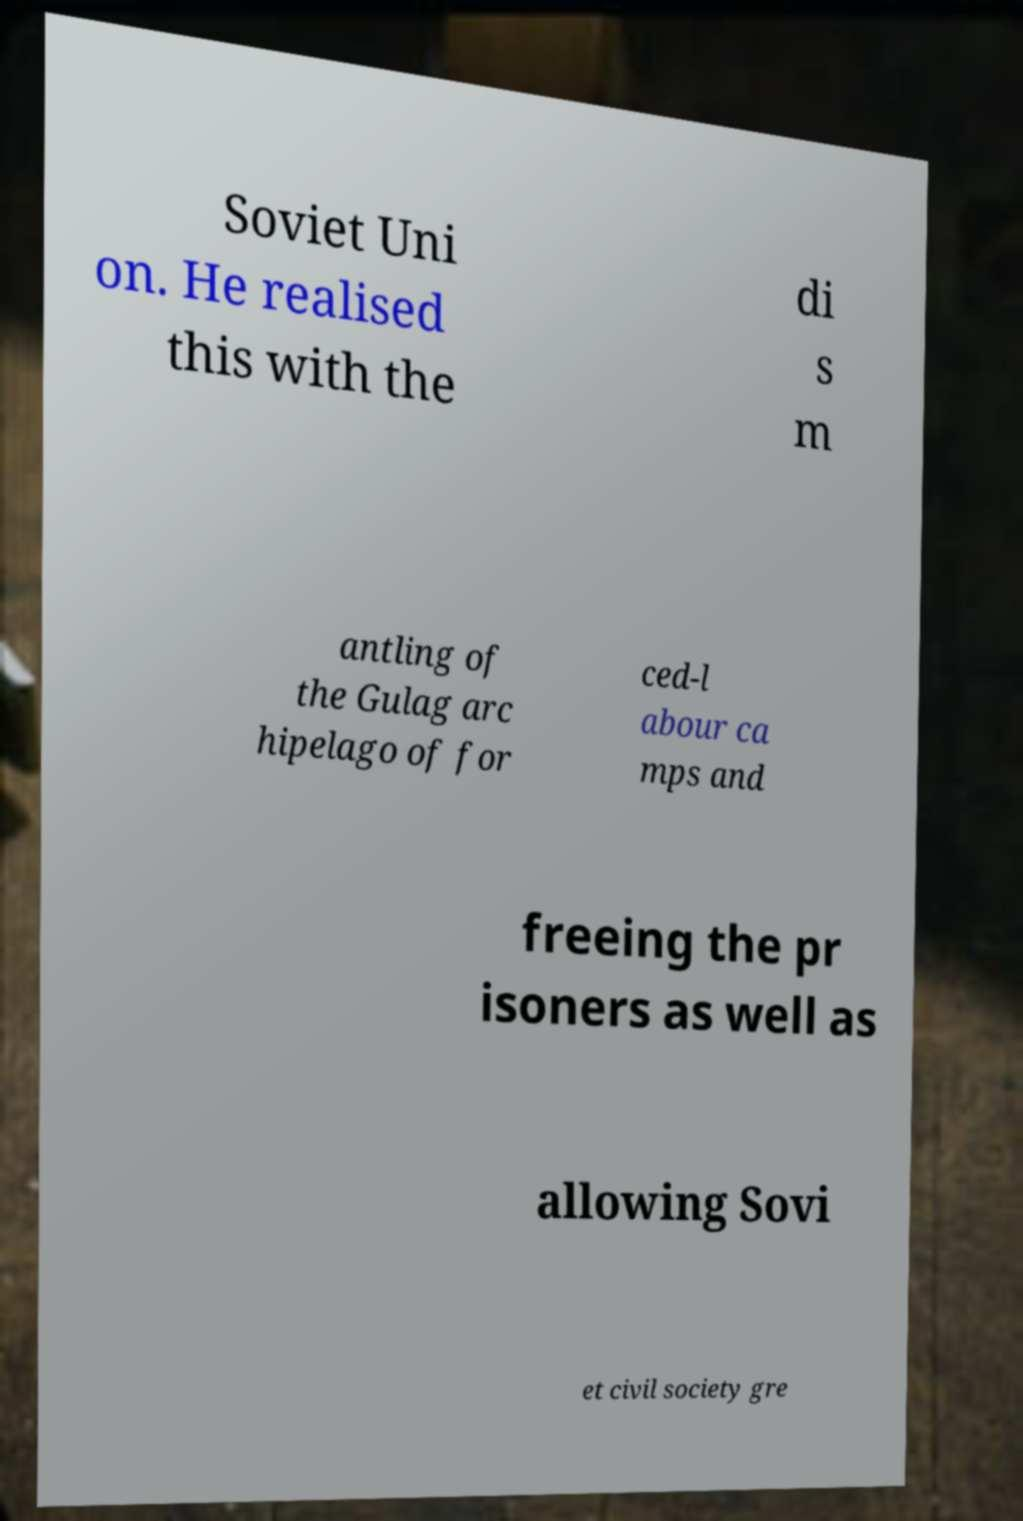What messages or text are displayed in this image? I need them in a readable, typed format. Soviet Uni on. He realised this with the di s m antling of the Gulag arc hipelago of for ced-l abour ca mps and freeing the pr isoners as well as allowing Sovi et civil society gre 